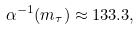Convert formula to latex. <formula><loc_0><loc_0><loc_500><loc_500>\alpha ^ { - 1 } ( m _ { \tau } ) \approx 1 3 3 . 3 ,</formula> 